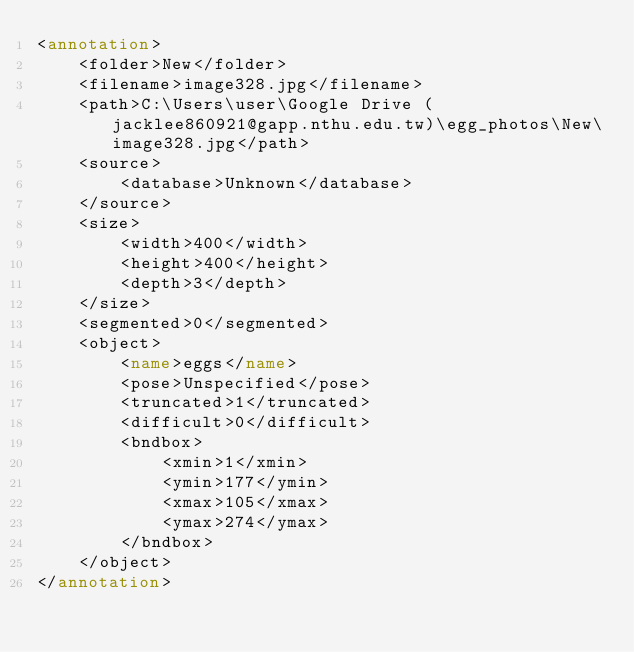<code> <loc_0><loc_0><loc_500><loc_500><_XML_><annotation>
	<folder>New</folder>
	<filename>image328.jpg</filename>
	<path>C:\Users\user\Google Drive (jacklee860921@gapp.nthu.edu.tw)\egg_photos\New\image328.jpg</path>
	<source>
		<database>Unknown</database>
	</source>
	<size>
		<width>400</width>
		<height>400</height>
		<depth>3</depth>
	</size>
	<segmented>0</segmented>
	<object>
		<name>eggs</name>
		<pose>Unspecified</pose>
		<truncated>1</truncated>
		<difficult>0</difficult>
		<bndbox>
			<xmin>1</xmin>
			<ymin>177</ymin>
			<xmax>105</xmax>
			<ymax>274</ymax>
		</bndbox>
	</object>
</annotation>
</code> 